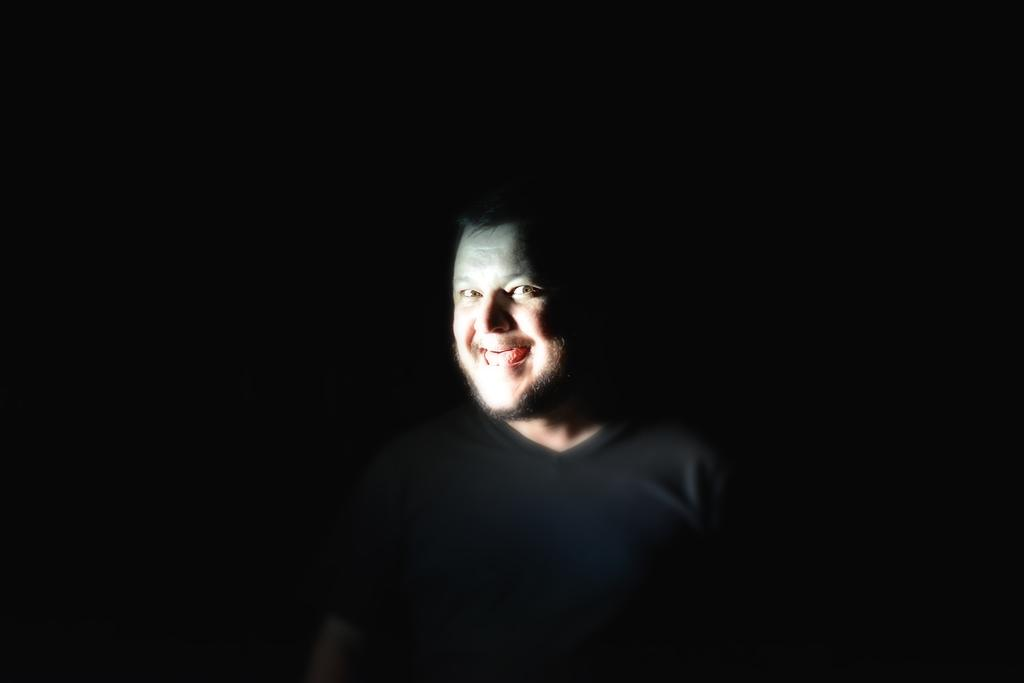What is the main subject of the image? A: There is a person in the center of the image. What type of wrench is being used by the person in the wilderness to measure the distance between two trees? There is no wrench or wilderness present in the image, and the person is not measuring any distances. 